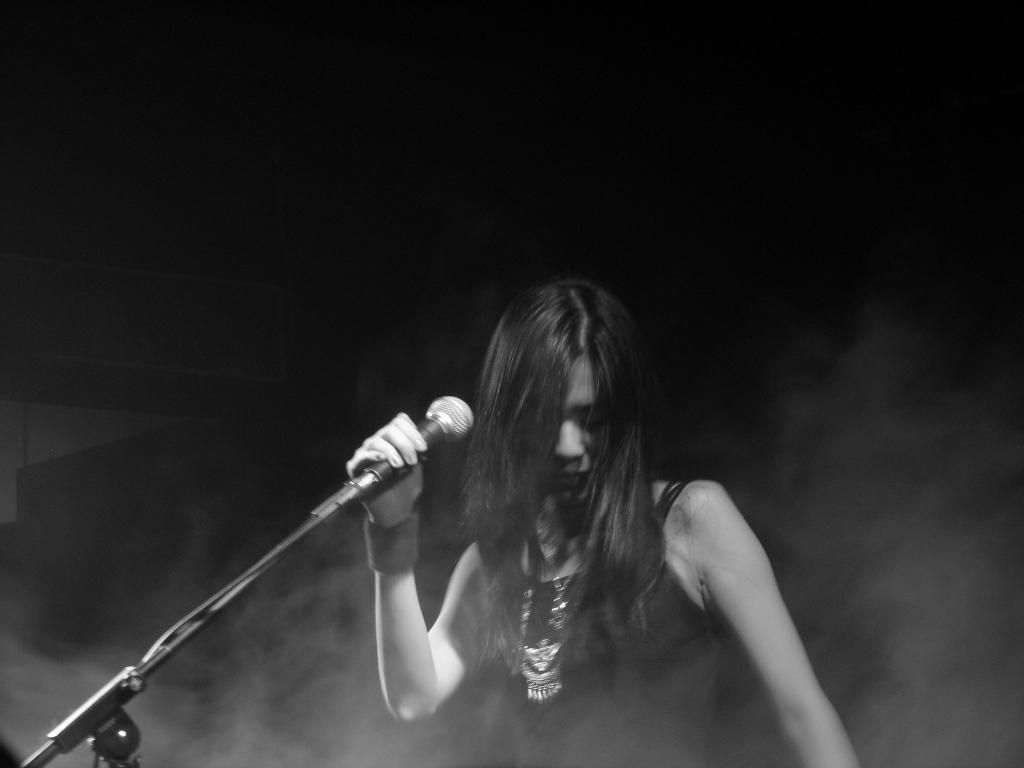Can you describe this image briefly? In this image there is a woman standing and holding a microphone in her hand , and there is a dark back ground. 